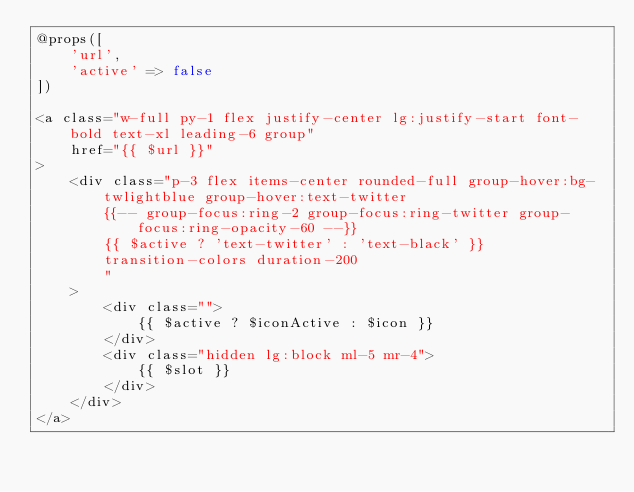Convert code to text. <code><loc_0><loc_0><loc_500><loc_500><_PHP_>@props([
    'url', 
    'active' => false
])

<a class="w-full py-1 flex justify-center lg:justify-start font-bold text-xl leading-6 group" 
    href="{{ $url }}"
>
    <div class="p-3 flex items-center rounded-full group-hover:bg-twlightblue group-hover:text-twitter 
        {{-- group-focus:ring-2 group-focus:ring-twitter group-focus:ring-opacity-60 --}}
        {{ $active ? 'text-twitter' : 'text-black' }}
        transition-colors duration-200
        "
    >
        <div class="">
            {{ $active ? $iconActive : $icon }}
        </div>
        <div class="hidden lg:block ml-5 mr-4">
            {{ $slot }}
        </div>
    </div>
</a>


</code> 